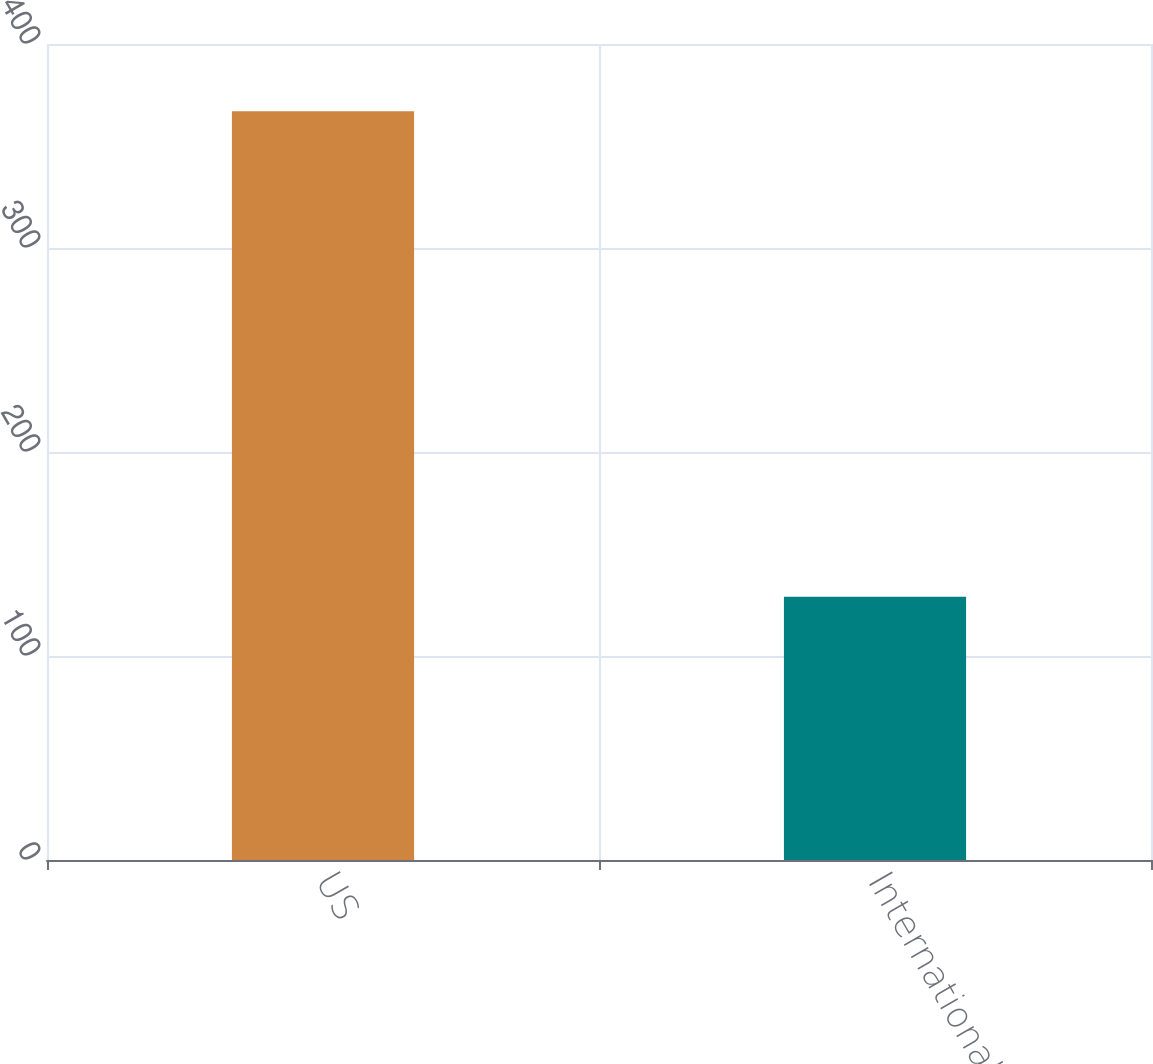Convert chart to OTSL. <chart><loc_0><loc_0><loc_500><loc_500><bar_chart><fcel>US<fcel>International<nl><fcel>367<fcel>129<nl></chart> 